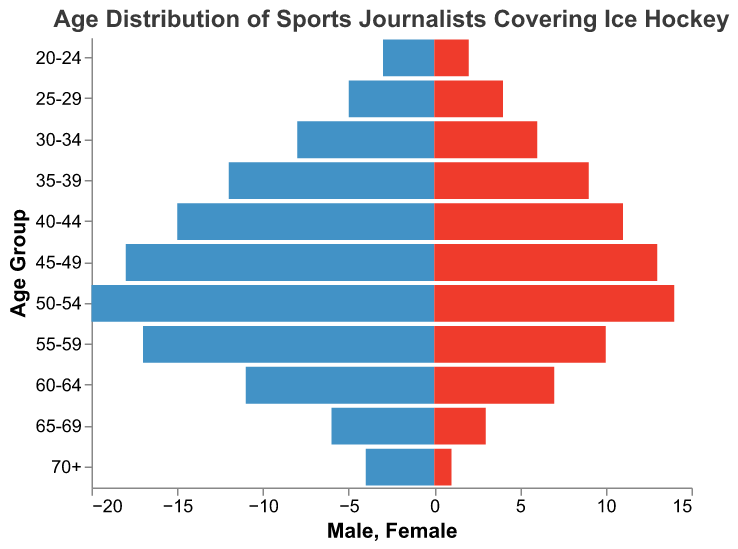What is the age group with the highest number of male sports journalists? The figure shows the distribution of male and female sports journalists across different age groups. By examining the male side of the pyramid, the age group 50-54 has the longest bar, indicating it has the highest number of male journalists.
Answer: 50-54 Which age group has the smallest difference between male and female sports journalists? By visually examining both sides of the pyramid, the age group 30-34 has 8 male and 6 female journalists, making the difference 2, which is smaller compared to other age groups.
Answer: 30-34 What is the total number of sports journalists aged 25-29? To find the total number of journalists in this age group, add the number of male (5) and female (4) journalists together. Therefore, 5 + 4 = 9.
Answer: 9 How many more male journalists are there than female journalists in the 45-49 age group? To find the difference, subtract the number of female journalists (13) from the number of male journalists (18) in that age group. So, 18 - 13 = 5.
Answer: 5 Which side of the pyramid is larger for the age group 60-64? By comparing the lengths of the bars on both sides of the pyramid for the age group 60-64, it's clear that the male side is longer with 11 journalists compared to 7 female journalists.
Answer: Male What's the average number of total sports journalists in the age groups between 30-34 and 40-44? First, find the total journalists for each age group: 30-34 has 8 males + 6 females = 14, 35-39 has 12 males + 9 females = 21, and 40-44 has 15 males + 11 females = 26. Then, the average number is (14 + 21 + 26) / 3 = 61 / 3 ≈ 20.33.
Answer: ~20.33 Which age group has the fewest female sports journalists? By visually comparing the lengths of the bars on the female side of the pyramid, the age group 70+ has the shortest bar with only 1 female journalist.
Answer: 70+ In which age group is the gender gap, in terms of absolute numbers, the most prominent? By examining the differences between the male and female sides for each age group, the age group 50-54 has the highest gap: 20 males and 14 females, making the gap 6.
Answer: 50-54 How do the number of female sports journalists aged 50-54 compare to those aged 20-24? By looking at the female side of the pyramid for each age group, there are 14 female journalists in the 50-54 group and 2 in the 20-24 group. Thus, 50-54 has 12 more female journalists than 20-24.
Answer: 50-54 has 12 more What's the median age group of sports journalists? To find the median age group, list all the age groups in order of total journalists. The middle value of 11 age groups is the 6th one: 25-29, 20-24, 65-69, 30-34, 60-64, 55-59, 35-39, 50-54, 45-49, 40-44, and 70+. The 6th group in order is 55-59.
Answer: 55-59 